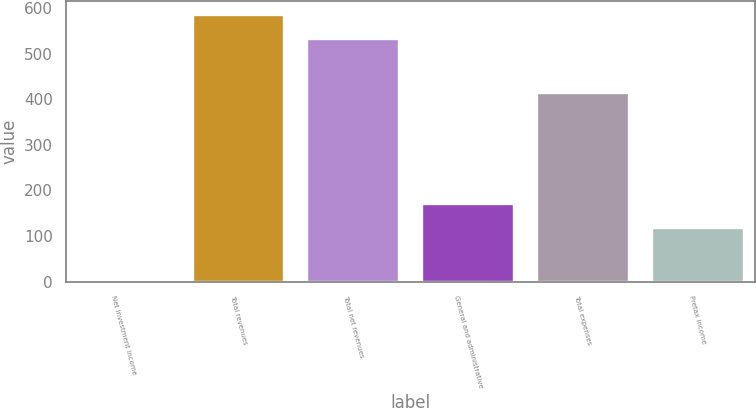Convert chart. <chart><loc_0><loc_0><loc_500><loc_500><bar_chart><fcel>Net investment income<fcel>Total revenues<fcel>Total net revenues<fcel>General and administrative<fcel>Total expenses<fcel>Pretax income<nl><fcel>3<fcel>585.1<fcel>532<fcel>171.1<fcel>414<fcel>118<nl></chart> 